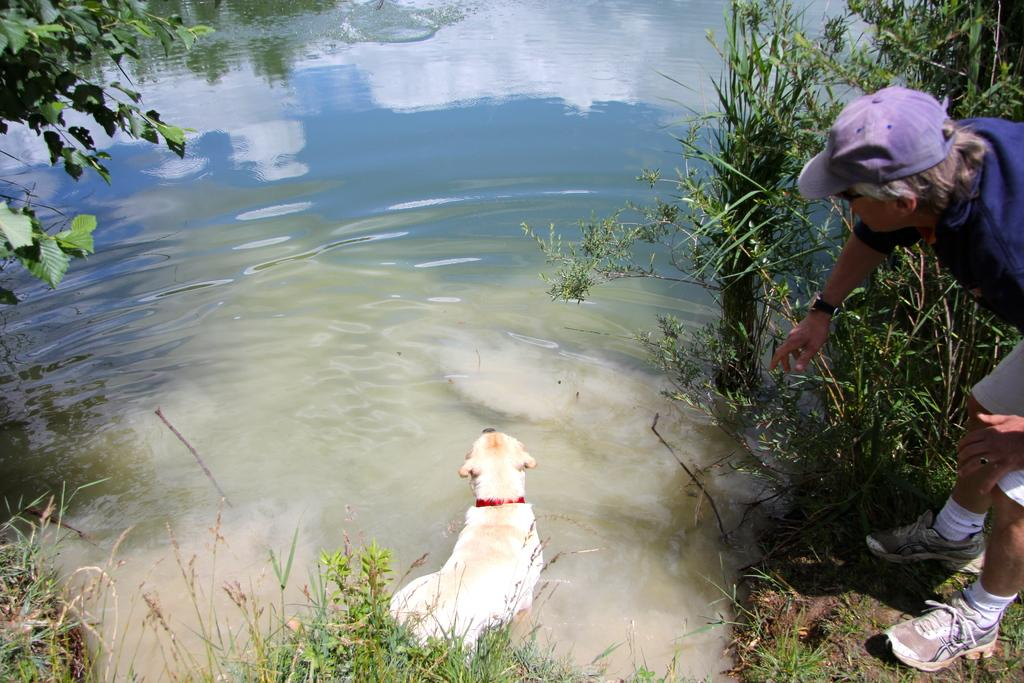What is the primary element in the image? The image consists of water. What animal can be seen at the bottom of the image? There is a dog at the bottom of the image. What type of vegetation is present at the bottom of the image? Green grass is present at the bottom of the image. Where are the plants located in the image? There are plants on both the left and right sides of the image. What is the person wearing on the right side of the image? There is a person wearing a blue cap on the right side of the image. What type of sound can be heard coming from the hospital in the image? There is no hospital present in the image, so it's not possible to determine what, if any, sounds might be heard. How many sheep are visible in the image? There are no sheep present in the image. 